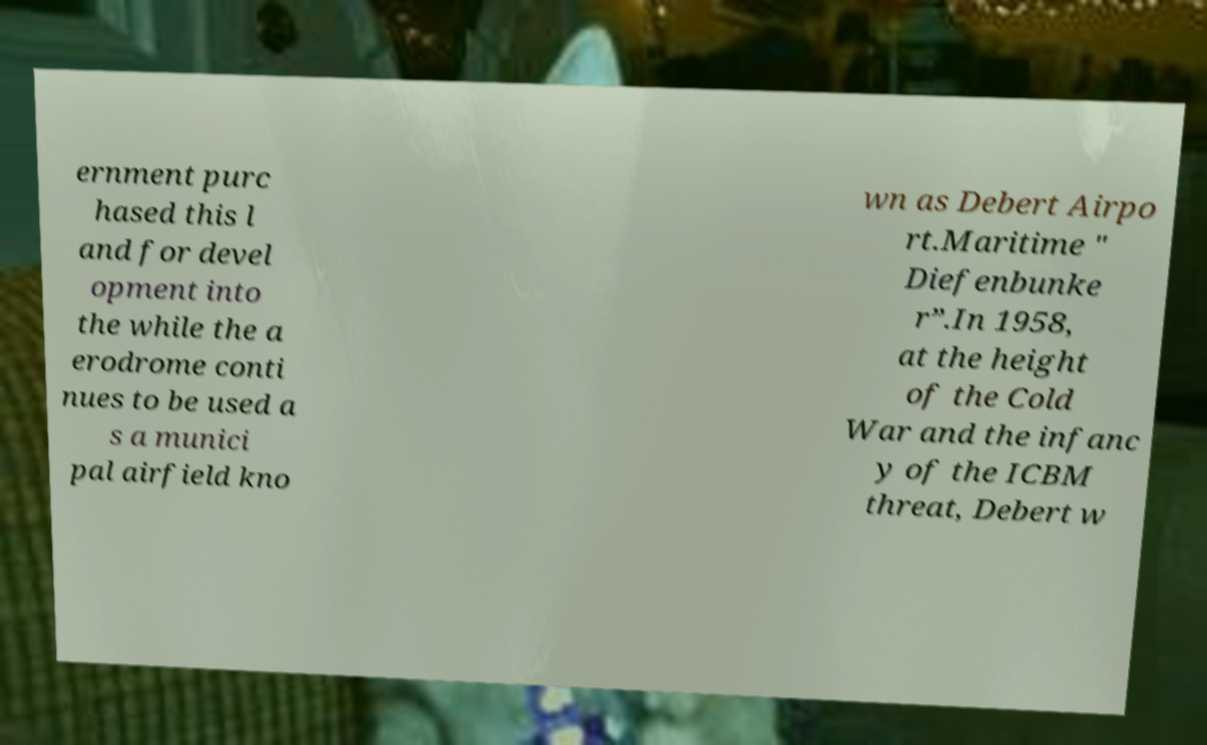Please read and relay the text visible in this image. What does it say? ernment purc hased this l and for devel opment into the while the a erodrome conti nues to be used a s a munici pal airfield kno wn as Debert Airpo rt.Maritime " Diefenbunke r”.In 1958, at the height of the Cold War and the infanc y of the ICBM threat, Debert w 